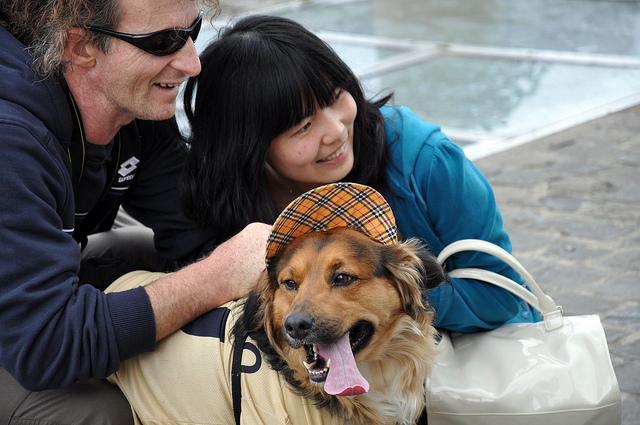Is it daytime?
Keep it brief. Yes. Why is this dog wearing a hat?
Give a very brief answer. Yes. Does the dog put the hat on himself?
Give a very brief answer. No. 